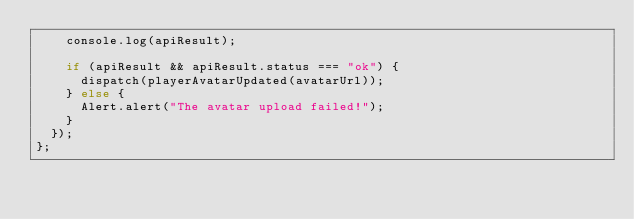Convert code to text. <code><loc_0><loc_0><loc_500><loc_500><_JavaScript_>    console.log(apiResult);

    if (apiResult && apiResult.status === "ok") {
      dispatch(playerAvatarUpdated(avatarUrl));
    } else {
      Alert.alert("The avatar upload failed!");
    }
  });
};
</code> 